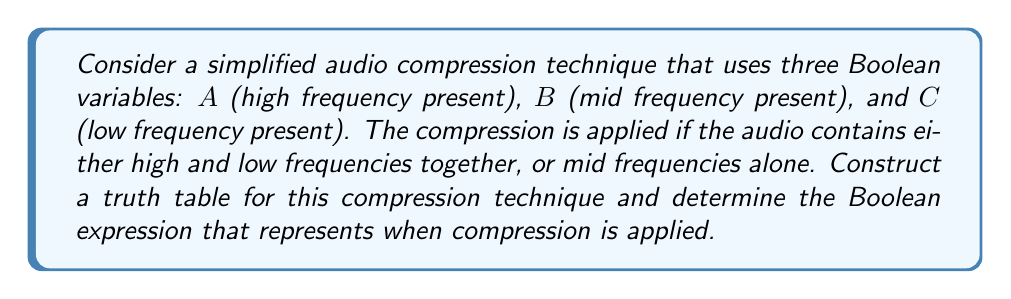Provide a solution to this math problem. Let's approach this step-by-step:

1) First, we need to create a truth table with three input variables (A, B, C) and one output (Compression).

2) We'll have $2^3 = 8$ possible input combinations.

3) Compression is applied when:
   - High and low frequencies are present together (A AND C)
   - OR
   - Mid frequencies are present alone (B AND NOT A AND NOT C)

4) Let's construct the truth table:

   $$
   \begin{array}{|c|c|c|c|}
   \hline
   A & B & C & \text{Compression} \\
   \hline
   0 & 0 & 0 & 0 \\
   0 & 0 & 1 & 0 \\
   0 & 1 & 0 & 1 \\
   0 & 1 & 1 & 0 \\
   1 & 0 & 0 & 0 \\
   1 & 0 & 1 & 1 \\
   1 & 1 & 0 & 0 \\
   1 & 1 & 1 & 1 \\
   \hline
   \end{array}
   $$

5) From this truth table, we can derive the Boolean expression:

   Compression = $(A \land C) \lor (B \land \lnot A \land \lnot C)$

6) This can be read as: "Compression is applied when (A AND C) OR (B AND NOT A AND NOT C)"
Answer: $(A \land C) \lor (B \land \lnot A \land \lnot C)$ 